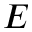<formula> <loc_0><loc_0><loc_500><loc_500>E</formula> 